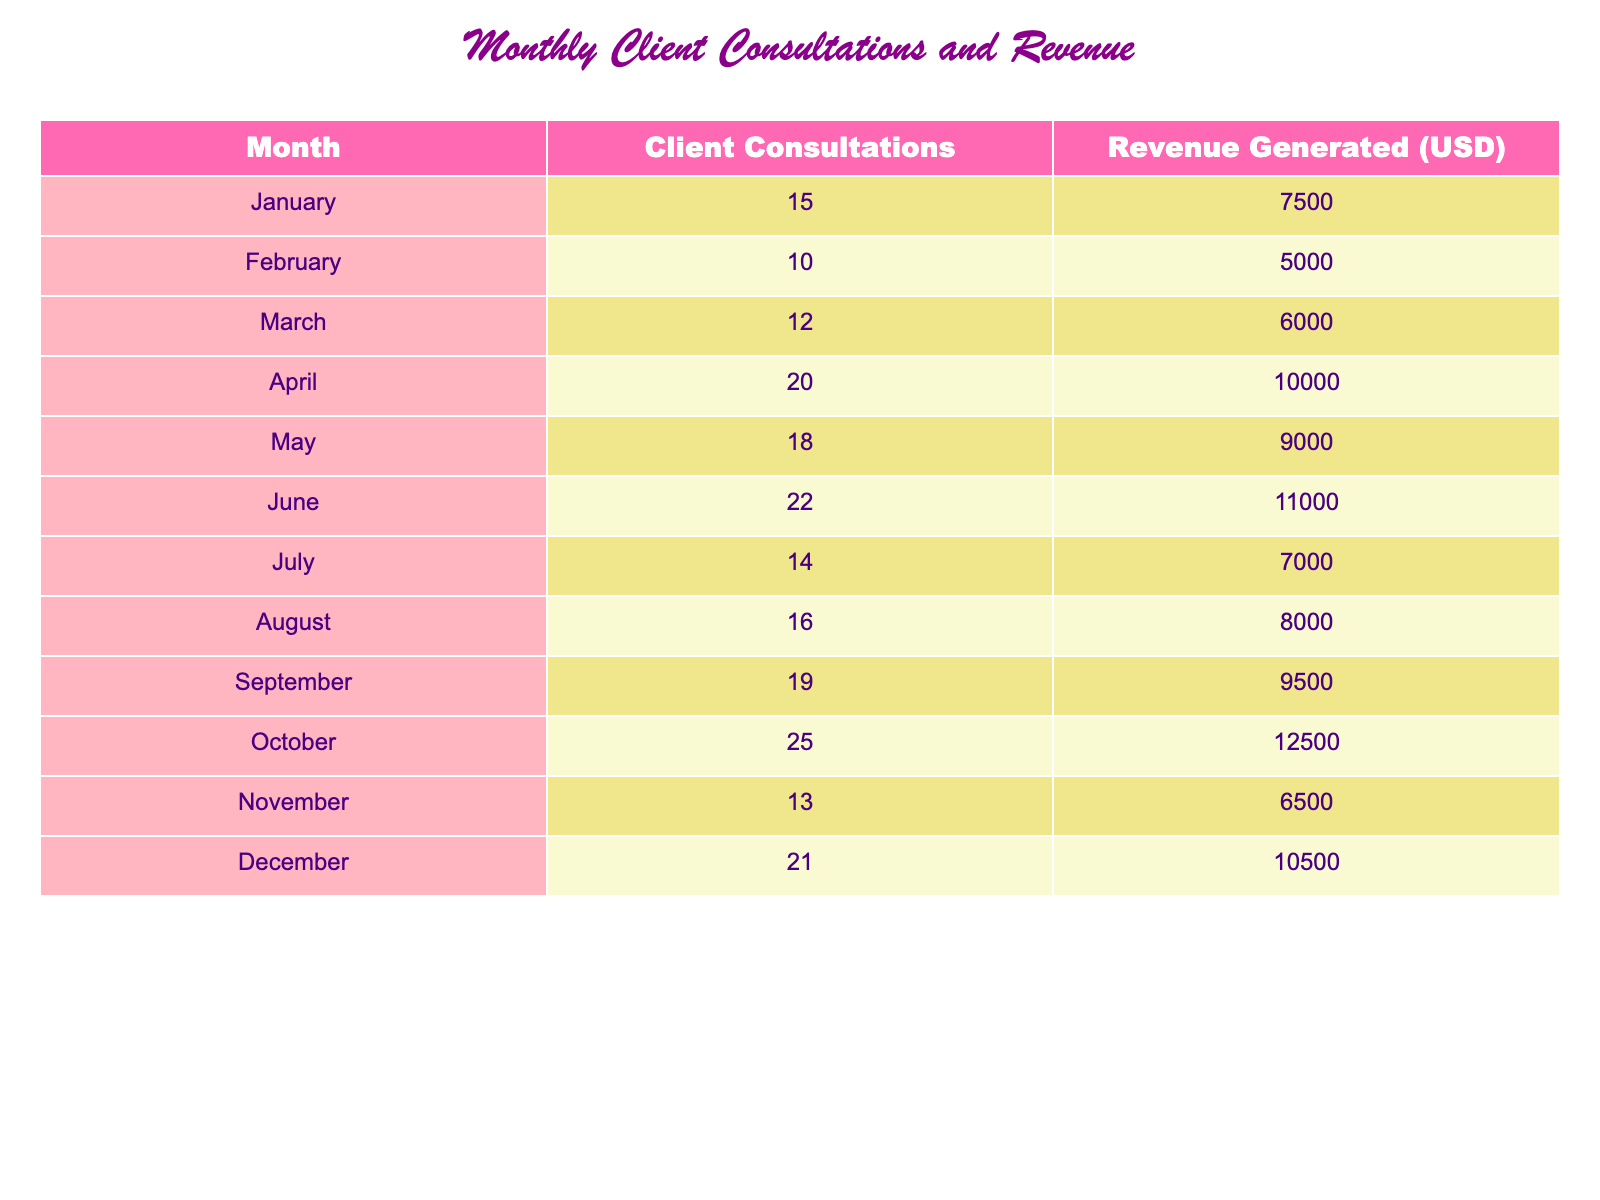What was the revenue generated in April? The table indicates that the revenue generated in April is specifically listed under that month. By checking the applicable column for April, we find the value of 10000 USD.
Answer: 10000 How many client consultations were there in June? Looking at the table for June, we can find the corresponding row. The number of client consultations listed next to June is 22.
Answer: 22 What is the total revenue generated from January to March? To find the total revenue from January to March, we will sum the revenue for each month: January (7500) + February (5000) + March (6000) = 7500 + 5000 + 6000 = 18500.
Answer: 18500 Was the revenue generated in August more than in May? By comparing the values in the revenue column for August (8000) and May (9000), we see that 8000 is less than 9000. Therefore, the revenue in August is not more than in May.
Answer: No What is the average number of client consultations for the entire year? To find the average, first sum the total number of client consultations across the year: (15 + 10 + 12 + 20 + 18 + 22 + 14 + 16 + 19 + 25 + 13 + 21) = 225. There are 12 months in total, so the average is 225 / 12 = 18.75.
Answer: 18.75 Which month had the highest revenue and what was that amount? By reviewing the revenue values, October stands out with the highest revenue value of 12500. October is the only month with this maximum amount.
Answer: October, 12500 How many more consultations were there in October compared to November? We find the consultations for October (25) and November (13). The difference is calculated as 25 - 13 = 12. Therefore, there were 12 more consultations in October than in November.
Answer: 12 Did the revenue increase from September to October? Checking the revenue for September (9500) and October (12500), we see that the October amount is greater than that of September. This indicates a clear increase in revenue.
Answer: Yes What was the total revenue generated in the last quarter (October, November, December)? The total revenue for the last quarter is calculated as follows: October (12500) + November (6500) + December (10500) = 12500 + 6500 + 10500 = 29500.
Answer: 29500 